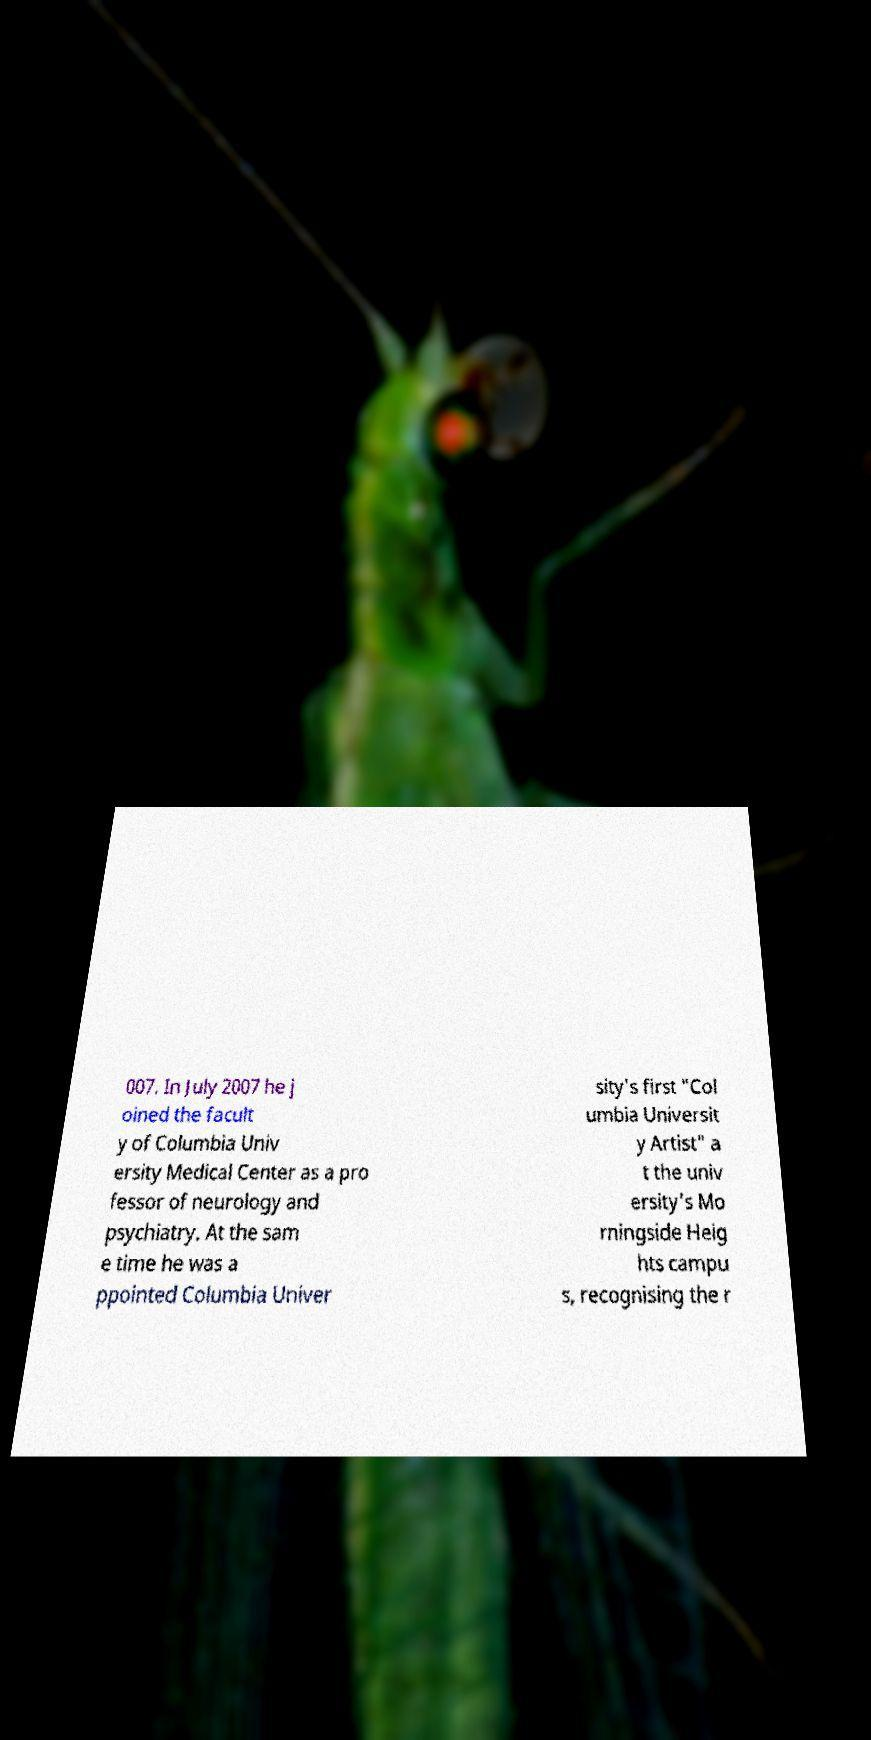There's text embedded in this image that I need extracted. Can you transcribe it verbatim? 007. In July 2007 he j oined the facult y of Columbia Univ ersity Medical Center as a pro fessor of neurology and psychiatry. At the sam e time he was a ppointed Columbia Univer sity's first "Col umbia Universit y Artist" a t the univ ersity's Mo rningside Heig hts campu s, recognising the r 